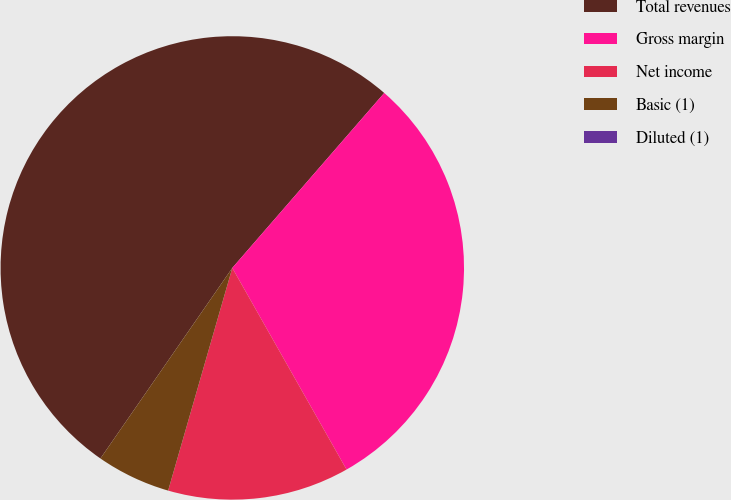Convert chart to OTSL. <chart><loc_0><loc_0><loc_500><loc_500><pie_chart><fcel>Total revenues<fcel>Gross margin<fcel>Net income<fcel>Basic (1)<fcel>Diluted (1)<nl><fcel>51.74%<fcel>30.41%<fcel>12.67%<fcel>5.17%<fcel>0.0%<nl></chart> 